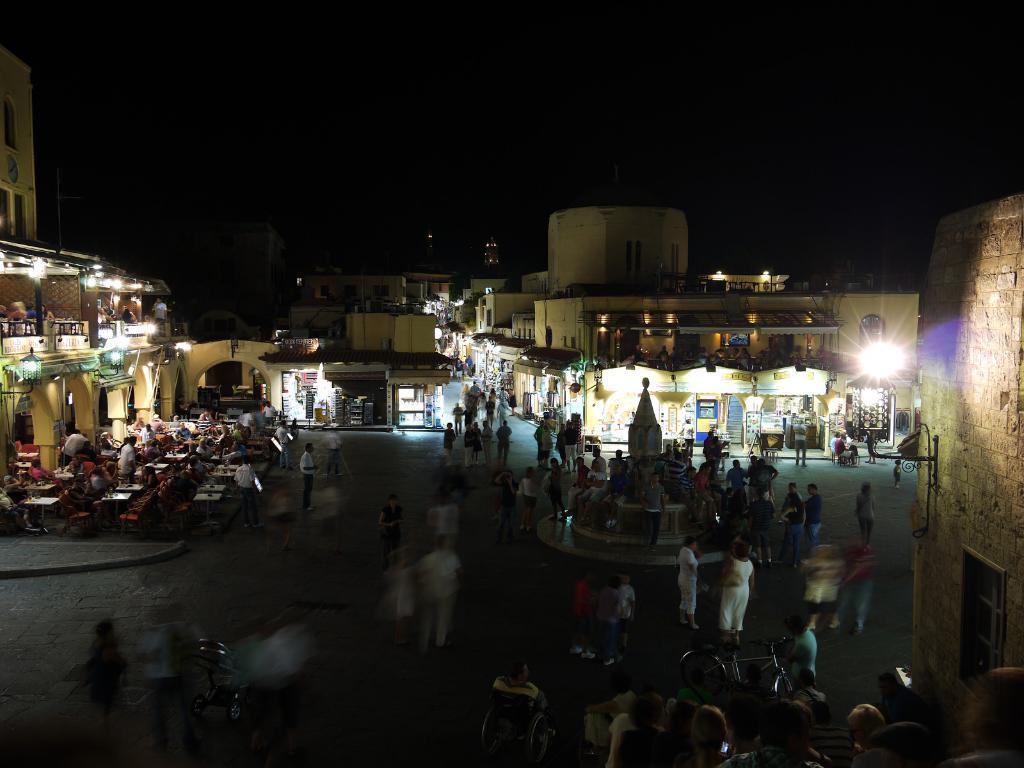Please provide a concise description of this image. In this image there are group of people and there are buildings and tables and chairs and there are lights on the buildings. At the top there is sky. At the bottom there is a road. 